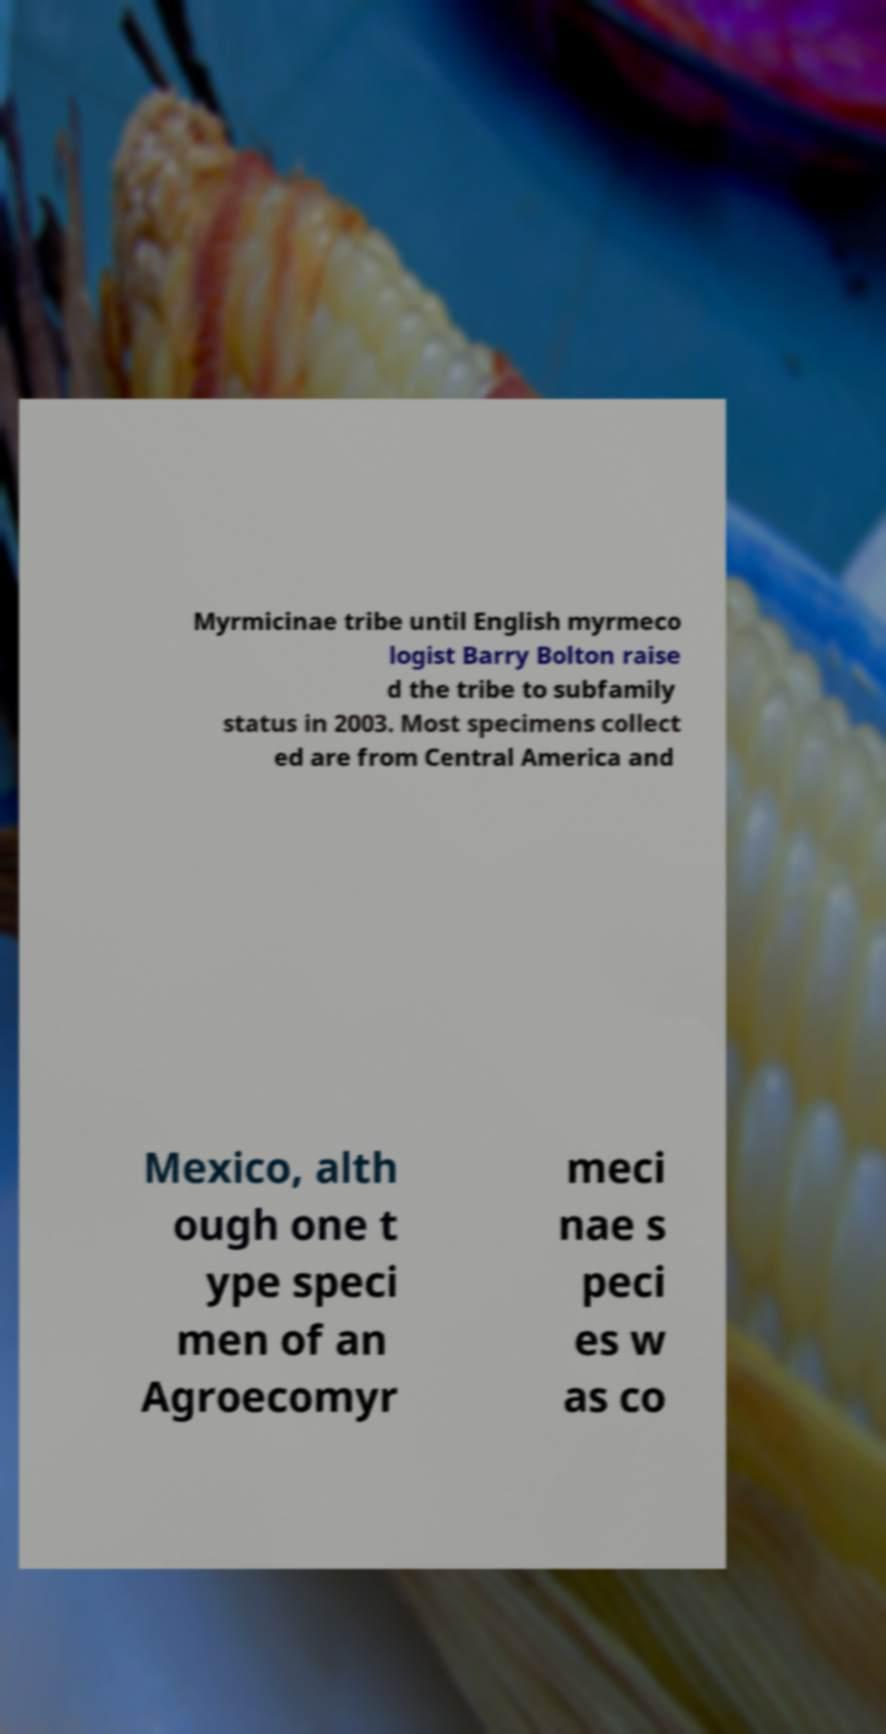There's text embedded in this image that I need extracted. Can you transcribe it verbatim? Myrmicinae tribe until English myrmeco logist Barry Bolton raise d the tribe to subfamily status in 2003. Most specimens collect ed are from Central America and Mexico, alth ough one t ype speci men of an Agroecomyr meci nae s peci es w as co 